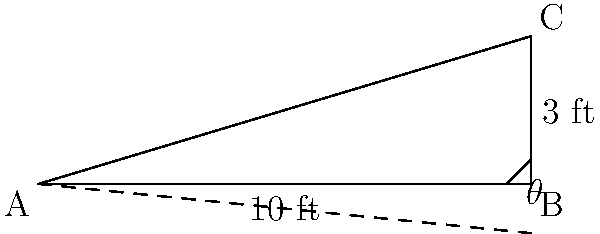For your 10th anniversary, you and your spouse decide to add a love seat to your patio. The patio has a slight slope, and you want to ensure the love seat is level. If the patio is 10 feet long and rises 3 feet over that distance, what is the angle of inclination ($\theta$) of the patio? Round your answer to the nearest degree. To find the angle of inclination ($\theta$), we can use the trigonometric function tangent. In a right triangle:

$\tan(\theta) = \frac{\text{opposite}}{\text{adjacent}}$

In this case:
1. The rise of 3 feet represents the opposite side.
2. The length of 10 feet represents the adjacent side.

Therefore:

$\tan(\theta) = \frac{3}{10} = 0.3$

To find $\theta$, we need to use the inverse tangent (arctan or $\tan^{-1}$):

$\theta = \tan^{-1}(0.3)$

Using a calculator or trigonometric tables:

$\theta \approx 16.70^\circ$

Rounding to the nearest degree:

$\theta \approx 17^\circ$
Answer: $17^\circ$ 